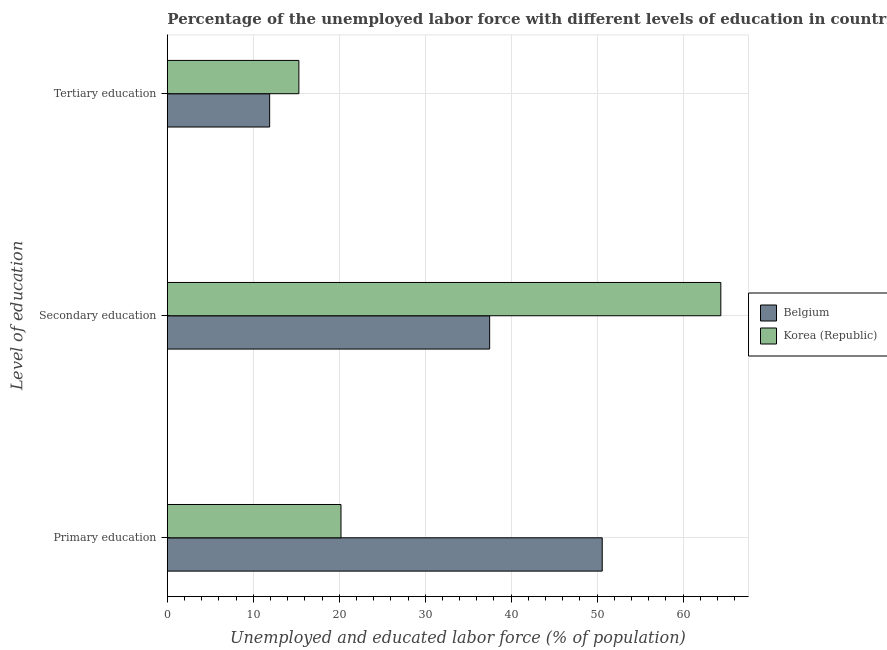How many different coloured bars are there?
Provide a succinct answer. 2. Are the number of bars on each tick of the Y-axis equal?
Provide a short and direct response. Yes. How many bars are there on the 1st tick from the top?
Make the answer very short. 2. What is the percentage of labor force who received primary education in Korea (Republic)?
Offer a very short reply. 20.2. Across all countries, what is the maximum percentage of labor force who received primary education?
Your answer should be compact. 50.6. Across all countries, what is the minimum percentage of labor force who received tertiary education?
Your answer should be compact. 11.9. In which country was the percentage of labor force who received secondary education maximum?
Your answer should be compact. Korea (Republic). In which country was the percentage of labor force who received tertiary education minimum?
Ensure brevity in your answer.  Belgium. What is the total percentage of labor force who received tertiary education in the graph?
Your answer should be very brief. 27.2. What is the difference between the percentage of labor force who received secondary education in Belgium and that in Korea (Republic)?
Provide a short and direct response. -26.9. What is the difference between the percentage of labor force who received primary education in Korea (Republic) and the percentage of labor force who received tertiary education in Belgium?
Provide a short and direct response. 8.3. What is the average percentage of labor force who received tertiary education per country?
Your answer should be compact. 13.6. What is the difference between the percentage of labor force who received secondary education and percentage of labor force who received primary education in Korea (Republic)?
Provide a succinct answer. 44.2. In how many countries, is the percentage of labor force who received primary education greater than 18 %?
Your answer should be very brief. 2. What is the ratio of the percentage of labor force who received tertiary education in Belgium to that in Korea (Republic)?
Make the answer very short. 0.78. Is the percentage of labor force who received primary education in Korea (Republic) less than that in Belgium?
Provide a short and direct response. Yes. Is the difference between the percentage of labor force who received tertiary education in Belgium and Korea (Republic) greater than the difference between the percentage of labor force who received secondary education in Belgium and Korea (Republic)?
Offer a terse response. Yes. What is the difference between the highest and the second highest percentage of labor force who received secondary education?
Your answer should be very brief. 26.9. What is the difference between the highest and the lowest percentage of labor force who received tertiary education?
Make the answer very short. 3.4. What does the 2nd bar from the bottom in Secondary education represents?
Provide a short and direct response. Korea (Republic). Is it the case that in every country, the sum of the percentage of labor force who received primary education and percentage of labor force who received secondary education is greater than the percentage of labor force who received tertiary education?
Provide a short and direct response. Yes. How many bars are there?
Offer a very short reply. 6. How many countries are there in the graph?
Ensure brevity in your answer.  2. Does the graph contain any zero values?
Provide a short and direct response. No. Does the graph contain grids?
Your answer should be compact. Yes. How many legend labels are there?
Your response must be concise. 2. What is the title of the graph?
Provide a short and direct response. Percentage of the unemployed labor force with different levels of education in countries. Does "Macedonia" appear as one of the legend labels in the graph?
Provide a short and direct response. No. What is the label or title of the X-axis?
Ensure brevity in your answer.  Unemployed and educated labor force (% of population). What is the label or title of the Y-axis?
Your response must be concise. Level of education. What is the Unemployed and educated labor force (% of population) of Belgium in Primary education?
Provide a succinct answer. 50.6. What is the Unemployed and educated labor force (% of population) of Korea (Republic) in Primary education?
Your answer should be very brief. 20.2. What is the Unemployed and educated labor force (% of population) in Belgium in Secondary education?
Offer a terse response. 37.5. What is the Unemployed and educated labor force (% of population) of Korea (Republic) in Secondary education?
Offer a terse response. 64.4. What is the Unemployed and educated labor force (% of population) of Belgium in Tertiary education?
Offer a very short reply. 11.9. What is the Unemployed and educated labor force (% of population) of Korea (Republic) in Tertiary education?
Offer a terse response. 15.3. Across all Level of education, what is the maximum Unemployed and educated labor force (% of population) of Belgium?
Provide a short and direct response. 50.6. Across all Level of education, what is the maximum Unemployed and educated labor force (% of population) of Korea (Republic)?
Offer a terse response. 64.4. Across all Level of education, what is the minimum Unemployed and educated labor force (% of population) of Belgium?
Make the answer very short. 11.9. Across all Level of education, what is the minimum Unemployed and educated labor force (% of population) of Korea (Republic)?
Keep it short and to the point. 15.3. What is the total Unemployed and educated labor force (% of population) of Belgium in the graph?
Make the answer very short. 100. What is the total Unemployed and educated labor force (% of population) of Korea (Republic) in the graph?
Ensure brevity in your answer.  99.9. What is the difference between the Unemployed and educated labor force (% of population) of Belgium in Primary education and that in Secondary education?
Your response must be concise. 13.1. What is the difference between the Unemployed and educated labor force (% of population) of Korea (Republic) in Primary education and that in Secondary education?
Provide a short and direct response. -44.2. What is the difference between the Unemployed and educated labor force (% of population) in Belgium in Primary education and that in Tertiary education?
Offer a very short reply. 38.7. What is the difference between the Unemployed and educated labor force (% of population) of Belgium in Secondary education and that in Tertiary education?
Your answer should be compact. 25.6. What is the difference between the Unemployed and educated labor force (% of population) of Korea (Republic) in Secondary education and that in Tertiary education?
Your answer should be compact. 49.1. What is the difference between the Unemployed and educated labor force (% of population) in Belgium in Primary education and the Unemployed and educated labor force (% of population) in Korea (Republic) in Secondary education?
Offer a very short reply. -13.8. What is the difference between the Unemployed and educated labor force (% of population) of Belgium in Primary education and the Unemployed and educated labor force (% of population) of Korea (Republic) in Tertiary education?
Provide a succinct answer. 35.3. What is the average Unemployed and educated labor force (% of population) of Belgium per Level of education?
Ensure brevity in your answer.  33.33. What is the average Unemployed and educated labor force (% of population) in Korea (Republic) per Level of education?
Your answer should be compact. 33.3. What is the difference between the Unemployed and educated labor force (% of population) of Belgium and Unemployed and educated labor force (% of population) of Korea (Republic) in Primary education?
Offer a terse response. 30.4. What is the difference between the Unemployed and educated labor force (% of population) of Belgium and Unemployed and educated labor force (% of population) of Korea (Republic) in Secondary education?
Your response must be concise. -26.9. What is the difference between the Unemployed and educated labor force (% of population) of Belgium and Unemployed and educated labor force (% of population) of Korea (Republic) in Tertiary education?
Make the answer very short. -3.4. What is the ratio of the Unemployed and educated labor force (% of population) of Belgium in Primary education to that in Secondary education?
Give a very brief answer. 1.35. What is the ratio of the Unemployed and educated labor force (% of population) in Korea (Republic) in Primary education to that in Secondary education?
Provide a short and direct response. 0.31. What is the ratio of the Unemployed and educated labor force (% of population) of Belgium in Primary education to that in Tertiary education?
Make the answer very short. 4.25. What is the ratio of the Unemployed and educated labor force (% of population) of Korea (Republic) in Primary education to that in Tertiary education?
Make the answer very short. 1.32. What is the ratio of the Unemployed and educated labor force (% of population) in Belgium in Secondary education to that in Tertiary education?
Keep it short and to the point. 3.15. What is the ratio of the Unemployed and educated labor force (% of population) of Korea (Republic) in Secondary education to that in Tertiary education?
Offer a terse response. 4.21. What is the difference between the highest and the second highest Unemployed and educated labor force (% of population) in Korea (Republic)?
Offer a very short reply. 44.2. What is the difference between the highest and the lowest Unemployed and educated labor force (% of population) of Belgium?
Keep it short and to the point. 38.7. What is the difference between the highest and the lowest Unemployed and educated labor force (% of population) of Korea (Republic)?
Offer a very short reply. 49.1. 